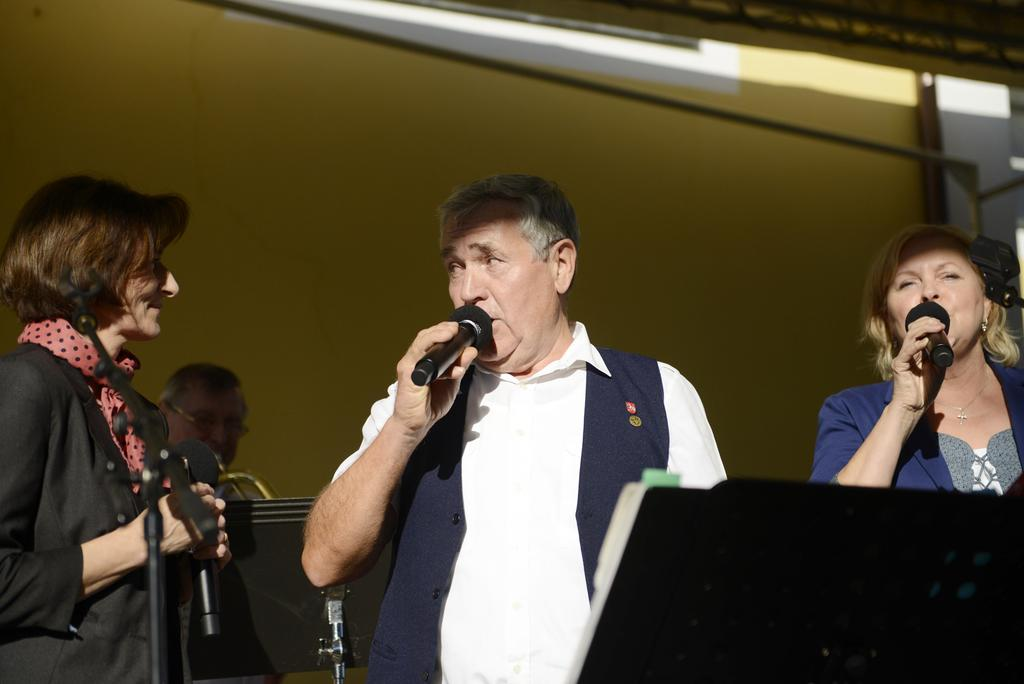What are the persons holding in the image? The persons are holding mics in the image. Where are the persons standing in the image? The persons are standing on a dais in the image. What can be seen in the background of the image? There is a person holding a musical instrument and a wall visible in the background. Can you see any water or rats in the image? No, there is no water or rats present in the image. How many steps are visible in the image? There are no steps visible in the image. 